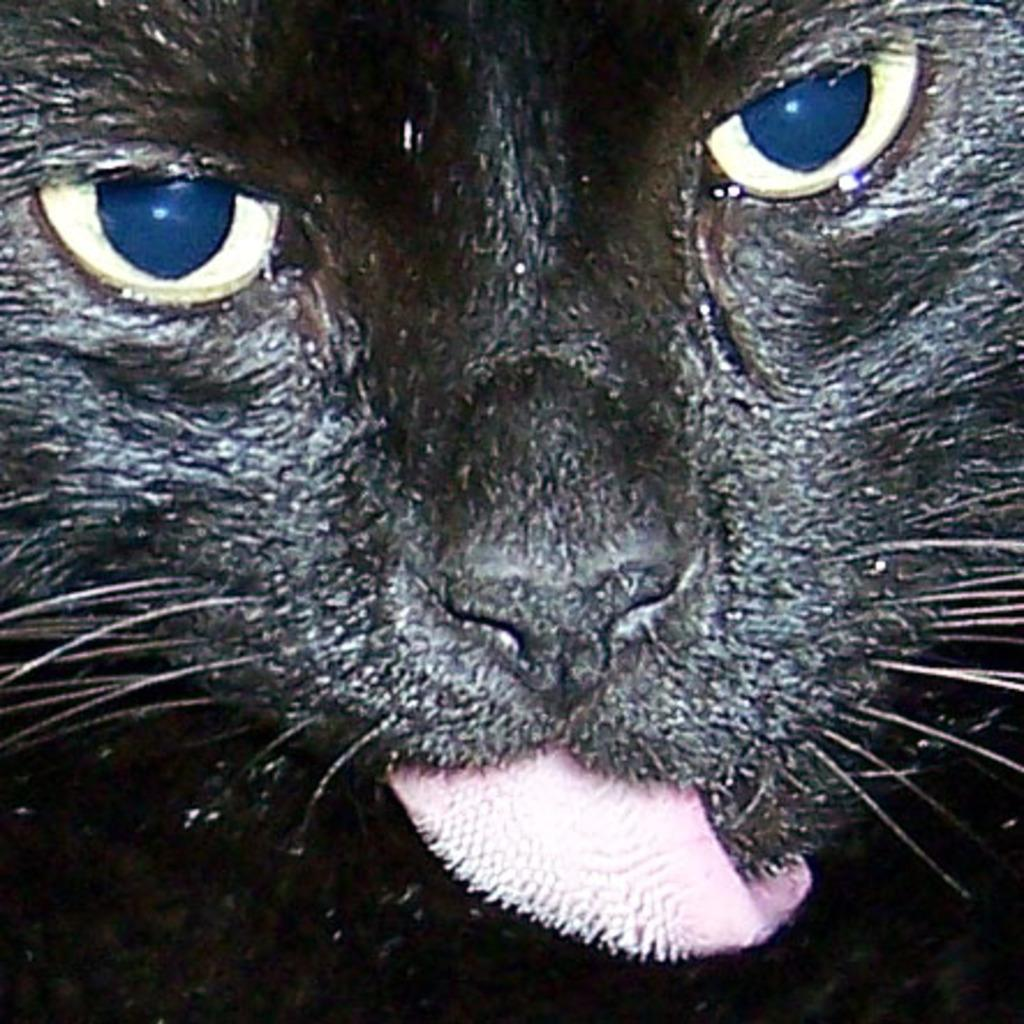What type of animal is in the image? There is a cat in the image. Can you describe the color of the cat? The cat is black in color. What type of glove is the cat wearing in the image? There is no glove present in the image, and cats do not wear gloves. 